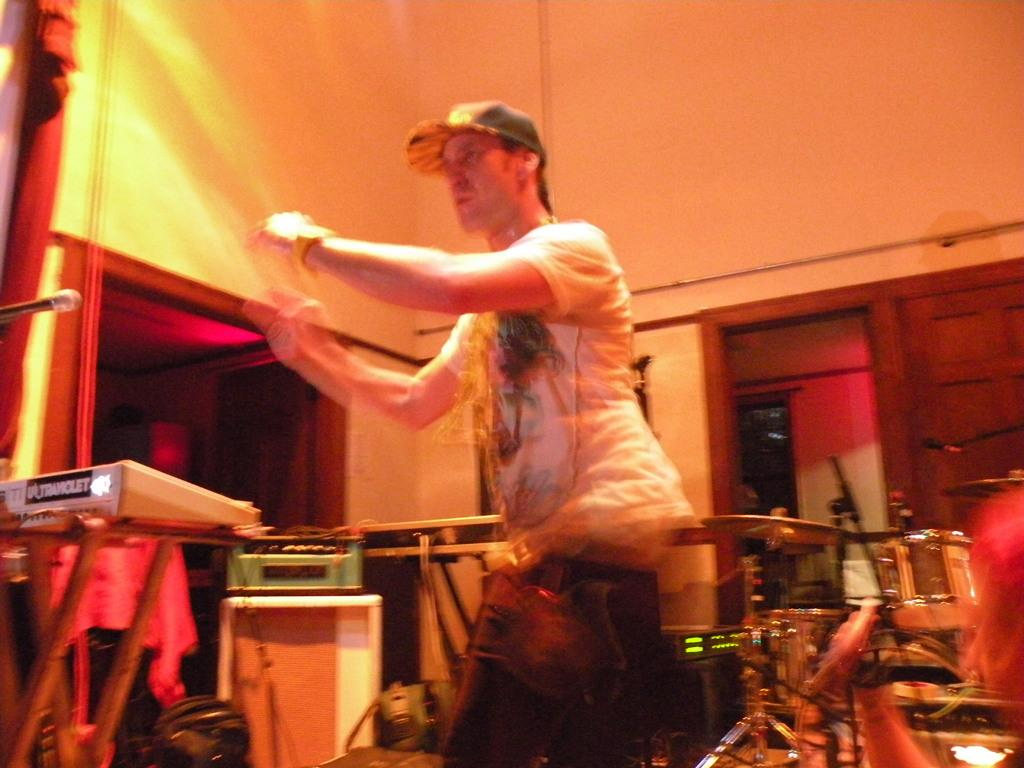What is the main subject of the image? There is a person standing in the image. What can be seen in the background of the image? There are musical instruments on a table and a wall visible in the background. How much dirt is present on the person's shoes in the image? There is no information about the person's shoes or the presence of dirt in the image. 